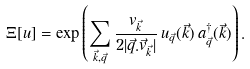Convert formula to latex. <formula><loc_0><loc_0><loc_500><loc_500>\Xi [ u ] = \exp \left ( \sum _ { \vec { k } , \vec { q } } \frac { v _ { \vec { k } } } { 2 | \vec { q } . \vec { v } _ { \vec { k } } | } \, u _ { \vec { q } } ( \vec { k } ) \, a ^ { \dag } _ { \vec { q } } ( \vec { k } ) \right ) .</formula> 